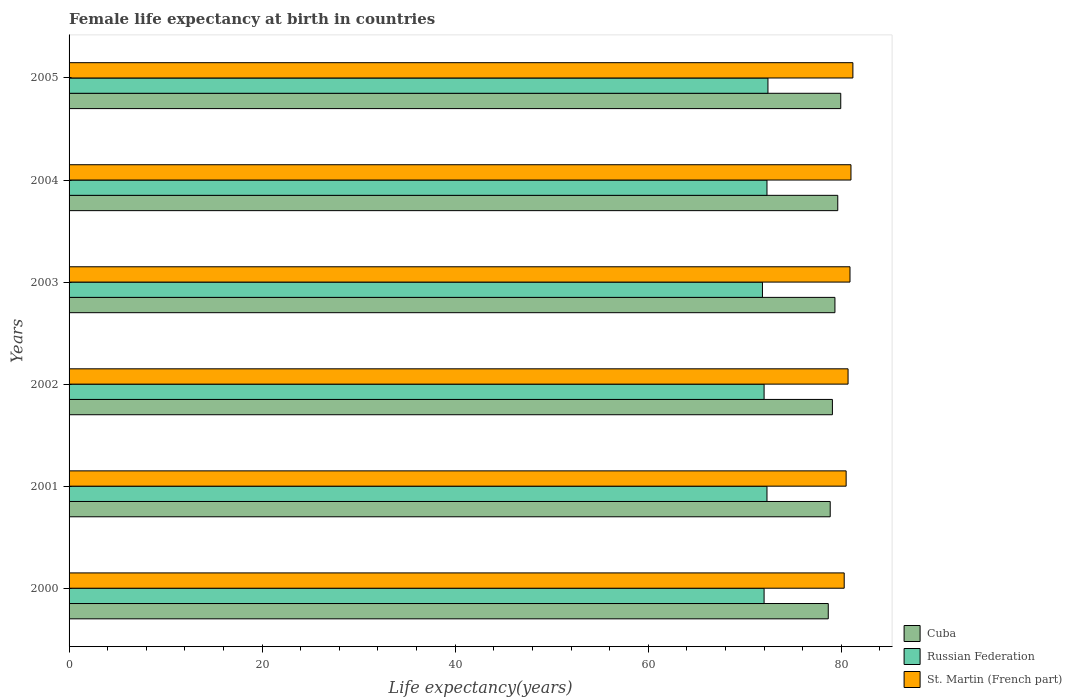How many different coloured bars are there?
Provide a short and direct response. 3. How many groups of bars are there?
Offer a terse response. 6. How many bars are there on the 2nd tick from the bottom?
Your response must be concise. 3. In how many cases, is the number of bars for a given year not equal to the number of legend labels?
Make the answer very short. 0. What is the female life expectancy at birth in Cuba in 2001?
Provide a succinct answer. 78.85. Across all years, what is the maximum female life expectancy at birth in Russian Federation?
Keep it short and to the point. 72.4. Across all years, what is the minimum female life expectancy at birth in Russian Federation?
Offer a very short reply. 71.83. In which year was the female life expectancy at birth in Russian Federation maximum?
Offer a terse response. 2005. In which year was the female life expectancy at birth in St. Martin (French part) minimum?
Provide a short and direct response. 2000. What is the total female life expectancy at birth in St. Martin (French part) in the graph?
Keep it short and to the point. 484.6. What is the difference between the female life expectancy at birth in St. Martin (French part) in 2002 and that in 2005?
Offer a terse response. -0.5. What is the difference between the female life expectancy at birth in Cuba in 2005 and the female life expectancy at birth in Russian Federation in 2001?
Your answer should be very brief. 7.64. What is the average female life expectancy at birth in Russian Federation per year?
Provide a succinct answer. 72.14. In the year 2004, what is the difference between the female life expectancy at birth in St. Martin (French part) and female life expectancy at birth in Russian Federation?
Your answer should be very brief. 8.7. In how many years, is the female life expectancy at birth in Cuba greater than 28 years?
Offer a terse response. 6. What is the ratio of the female life expectancy at birth in Cuba in 2003 to that in 2004?
Offer a terse response. 1. What is the difference between the highest and the second highest female life expectancy at birth in St. Martin (French part)?
Your response must be concise. 0.2. What is the difference between the highest and the lowest female life expectancy at birth in St. Martin (French part)?
Provide a succinct answer. 0.9. What does the 1st bar from the top in 2000 represents?
Provide a succinct answer. St. Martin (French part). What does the 3rd bar from the bottom in 2000 represents?
Provide a succinct answer. St. Martin (French part). Is it the case that in every year, the sum of the female life expectancy at birth in St. Martin (French part) and female life expectancy at birth in Cuba is greater than the female life expectancy at birth in Russian Federation?
Make the answer very short. Yes. How many bars are there?
Your answer should be compact. 18. What is the difference between two consecutive major ticks on the X-axis?
Ensure brevity in your answer.  20. Are the values on the major ticks of X-axis written in scientific E-notation?
Make the answer very short. No. Does the graph contain any zero values?
Make the answer very short. No. Does the graph contain grids?
Your answer should be very brief. No. Where does the legend appear in the graph?
Offer a terse response. Bottom right. How many legend labels are there?
Give a very brief answer. 3. What is the title of the graph?
Your answer should be compact. Female life expectancy at birth in countries. What is the label or title of the X-axis?
Keep it short and to the point. Life expectancy(years). What is the label or title of the Y-axis?
Provide a short and direct response. Years. What is the Life expectancy(years) in Cuba in 2000?
Keep it short and to the point. 78.65. What is the Life expectancy(years) of St. Martin (French part) in 2000?
Provide a short and direct response. 80.3. What is the Life expectancy(years) in Cuba in 2001?
Ensure brevity in your answer.  78.85. What is the Life expectancy(years) in Russian Federation in 2001?
Offer a terse response. 72.3. What is the Life expectancy(years) of St. Martin (French part) in 2001?
Your response must be concise. 80.5. What is the Life expectancy(years) of Cuba in 2002?
Your answer should be compact. 79.08. What is the Life expectancy(years) in Russian Federation in 2002?
Keep it short and to the point. 72. What is the Life expectancy(years) of St. Martin (French part) in 2002?
Your answer should be compact. 80.7. What is the Life expectancy(years) in Cuba in 2003?
Give a very brief answer. 79.34. What is the Life expectancy(years) in Russian Federation in 2003?
Provide a succinct answer. 71.83. What is the Life expectancy(years) of St. Martin (French part) in 2003?
Ensure brevity in your answer.  80.9. What is the Life expectancy(years) of Cuba in 2004?
Offer a terse response. 79.63. What is the Life expectancy(years) in Russian Federation in 2004?
Ensure brevity in your answer.  72.3. What is the Life expectancy(years) in St. Martin (French part) in 2004?
Your answer should be very brief. 81. What is the Life expectancy(years) of Cuba in 2005?
Your response must be concise. 79.94. What is the Life expectancy(years) of Russian Federation in 2005?
Give a very brief answer. 72.4. What is the Life expectancy(years) in St. Martin (French part) in 2005?
Your answer should be very brief. 81.2. Across all years, what is the maximum Life expectancy(years) of Cuba?
Your answer should be very brief. 79.94. Across all years, what is the maximum Life expectancy(years) of Russian Federation?
Your answer should be very brief. 72.4. Across all years, what is the maximum Life expectancy(years) of St. Martin (French part)?
Keep it short and to the point. 81.2. Across all years, what is the minimum Life expectancy(years) in Cuba?
Provide a succinct answer. 78.65. Across all years, what is the minimum Life expectancy(years) in Russian Federation?
Make the answer very short. 71.83. Across all years, what is the minimum Life expectancy(years) in St. Martin (French part)?
Your response must be concise. 80.3. What is the total Life expectancy(years) of Cuba in the graph?
Offer a terse response. 475.49. What is the total Life expectancy(years) in Russian Federation in the graph?
Your answer should be compact. 432.83. What is the total Life expectancy(years) of St. Martin (French part) in the graph?
Your response must be concise. 484.6. What is the difference between the Life expectancy(years) in Cuba in 2000 and that in 2001?
Give a very brief answer. -0.2. What is the difference between the Life expectancy(years) of Russian Federation in 2000 and that in 2001?
Make the answer very short. -0.3. What is the difference between the Life expectancy(years) of St. Martin (French part) in 2000 and that in 2001?
Ensure brevity in your answer.  -0.2. What is the difference between the Life expectancy(years) of Cuba in 2000 and that in 2002?
Offer a terse response. -0.43. What is the difference between the Life expectancy(years) in St. Martin (French part) in 2000 and that in 2002?
Ensure brevity in your answer.  -0.4. What is the difference between the Life expectancy(years) of Cuba in 2000 and that in 2003?
Provide a succinct answer. -0.69. What is the difference between the Life expectancy(years) of Russian Federation in 2000 and that in 2003?
Provide a short and direct response. 0.17. What is the difference between the Life expectancy(years) in Cuba in 2000 and that in 2004?
Your answer should be very brief. -0.98. What is the difference between the Life expectancy(years) of Cuba in 2000 and that in 2005?
Offer a very short reply. -1.29. What is the difference between the Life expectancy(years) of Cuba in 2001 and that in 2002?
Your answer should be very brief. -0.23. What is the difference between the Life expectancy(years) of Russian Federation in 2001 and that in 2002?
Your response must be concise. 0.3. What is the difference between the Life expectancy(years) in St. Martin (French part) in 2001 and that in 2002?
Offer a very short reply. -0.2. What is the difference between the Life expectancy(years) of Cuba in 2001 and that in 2003?
Make the answer very short. -0.49. What is the difference between the Life expectancy(years) in Russian Federation in 2001 and that in 2003?
Provide a short and direct response. 0.47. What is the difference between the Life expectancy(years) in St. Martin (French part) in 2001 and that in 2003?
Your answer should be very brief. -0.4. What is the difference between the Life expectancy(years) of Cuba in 2001 and that in 2004?
Your answer should be very brief. -0.78. What is the difference between the Life expectancy(years) of St. Martin (French part) in 2001 and that in 2004?
Ensure brevity in your answer.  -0.5. What is the difference between the Life expectancy(years) in Cuba in 2001 and that in 2005?
Offer a very short reply. -1.09. What is the difference between the Life expectancy(years) in Russian Federation in 2001 and that in 2005?
Your answer should be compact. -0.1. What is the difference between the Life expectancy(years) of St. Martin (French part) in 2001 and that in 2005?
Give a very brief answer. -0.7. What is the difference between the Life expectancy(years) in Cuba in 2002 and that in 2003?
Offer a very short reply. -0.26. What is the difference between the Life expectancy(years) in Russian Federation in 2002 and that in 2003?
Your answer should be very brief. 0.17. What is the difference between the Life expectancy(years) of St. Martin (French part) in 2002 and that in 2003?
Ensure brevity in your answer.  -0.2. What is the difference between the Life expectancy(years) in Cuba in 2002 and that in 2004?
Offer a terse response. -0.55. What is the difference between the Life expectancy(years) in St. Martin (French part) in 2002 and that in 2004?
Offer a very short reply. -0.3. What is the difference between the Life expectancy(years) of Cuba in 2002 and that in 2005?
Make the answer very short. -0.86. What is the difference between the Life expectancy(years) of St. Martin (French part) in 2002 and that in 2005?
Ensure brevity in your answer.  -0.5. What is the difference between the Life expectancy(years) in Cuba in 2003 and that in 2004?
Your response must be concise. -0.29. What is the difference between the Life expectancy(years) in Russian Federation in 2003 and that in 2004?
Offer a very short reply. -0.47. What is the difference between the Life expectancy(years) of Cuba in 2003 and that in 2005?
Your response must be concise. -0.6. What is the difference between the Life expectancy(years) in Russian Federation in 2003 and that in 2005?
Keep it short and to the point. -0.57. What is the difference between the Life expectancy(years) of Cuba in 2004 and that in 2005?
Provide a short and direct response. -0.31. What is the difference between the Life expectancy(years) of Russian Federation in 2004 and that in 2005?
Make the answer very short. -0.1. What is the difference between the Life expectancy(years) of St. Martin (French part) in 2004 and that in 2005?
Make the answer very short. -0.2. What is the difference between the Life expectancy(years) in Cuba in 2000 and the Life expectancy(years) in Russian Federation in 2001?
Offer a very short reply. 6.35. What is the difference between the Life expectancy(years) in Cuba in 2000 and the Life expectancy(years) in St. Martin (French part) in 2001?
Offer a terse response. -1.85. What is the difference between the Life expectancy(years) of Russian Federation in 2000 and the Life expectancy(years) of St. Martin (French part) in 2001?
Offer a very short reply. -8.5. What is the difference between the Life expectancy(years) in Cuba in 2000 and the Life expectancy(years) in Russian Federation in 2002?
Your answer should be compact. 6.65. What is the difference between the Life expectancy(years) in Cuba in 2000 and the Life expectancy(years) in St. Martin (French part) in 2002?
Keep it short and to the point. -2.05. What is the difference between the Life expectancy(years) in Cuba in 2000 and the Life expectancy(years) in Russian Federation in 2003?
Your answer should be compact. 6.82. What is the difference between the Life expectancy(years) of Cuba in 2000 and the Life expectancy(years) of St. Martin (French part) in 2003?
Offer a very short reply. -2.25. What is the difference between the Life expectancy(years) in Russian Federation in 2000 and the Life expectancy(years) in St. Martin (French part) in 2003?
Keep it short and to the point. -8.9. What is the difference between the Life expectancy(years) in Cuba in 2000 and the Life expectancy(years) in Russian Federation in 2004?
Ensure brevity in your answer.  6.35. What is the difference between the Life expectancy(years) in Cuba in 2000 and the Life expectancy(years) in St. Martin (French part) in 2004?
Make the answer very short. -2.35. What is the difference between the Life expectancy(years) in Russian Federation in 2000 and the Life expectancy(years) in St. Martin (French part) in 2004?
Provide a short and direct response. -9. What is the difference between the Life expectancy(years) of Cuba in 2000 and the Life expectancy(years) of Russian Federation in 2005?
Give a very brief answer. 6.25. What is the difference between the Life expectancy(years) of Cuba in 2000 and the Life expectancy(years) of St. Martin (French part) in 2005?
Ensure brevity in your answer.  -2.55. What is the difference between the Life expectancy(years) in Russian Federation in 2000 and the Life expectancy(years) in St. Martin (French part) in 2005?
Your answer should be compact. -9.2. What is the difference between the Life expectancy(years) of Cuba in 2001 and the Life expectancy(years) of Russian Federation in 2002?
Give a very brief answer. 6.85. What is the difference between the Life expectancy(years) of Cuba in 2001 and the Life expectancy(years) of St. Martin (French part) in 2002?
Give a very brief answer. -1.85. What is the difference between the Life expectancy(years) of Cuba in 2001 and the Life expectancy(years) of Russian Federation in 2003?
Give a very brief answer. 7.02. What is the difference between the Life expectancy(years) in Cuba in 2001 and the Life expectancy(years) in St. Martin (French part) in 2003?
Offer a terse response. -2.05. What is the difference between the Life expectancy(years) in Cuba in 2001 and the Life expectancy(years) in Russian Federation in 2004?
Your answer should be compact. 6.55. What is the difference between the Life expectancy(years) of Cuba in 2001 and the Life expectancy(years) of St. Martin (French part) in 2004?
Give a very brief answer. -2.15. What is the difference between the Life expectancy(years) of Cuba in 2001 and the Life expectancy(years) of Russian Federation in 2005?
Your answer should be very brief. 6.45. What is the difference between the Life expectancy(years) in Cuba in 2001 and the Life expectancy(years) in St. Martin (French part) in 2005?
Provide a short and direct response. -2.35. What is the difference between the Life expectancy(years) of Cuba in 2002 and the Life expectancy(years) of Russian Federation in 2003?
Ensure brevity in your answer.  7.25. What is the difference between the Life expectancy(years) of Cuba in 2002 and the Life expectancy(years) of St. Martin (French part) in 2003?
Give a very brief answer. -1.82. What is the difference between the Life expectancy(years) of Cuba in 2002 and the Life expectancy(years) of Russian Federation in 2004?
Offer a very short reply. 6.78. What is the difference between the Life expectancy(years) of Cuba in 2002 and the Life expectancy(years) of St. Martin (French part) in 2004?
Make the answer very short. -1.92. What is the difference between the Life expectancy(years) of Russian Federation in 2002 and the Life expectancy(years) of St. Martin (French part) in 2004?
Provide a succinct answer. -9. What is the difference between the Life expectancy(years) in Cuba in 2002 and the Life expectancy(years) in Russian Federation in 2005?
Keep it short and to the point. 6.68. What is the difference between the Life expectancy(years) of Cuba in 2002 and the Life expectancy(years) of St. Martin (French part) in 2005?
Your answer should be compact. -2.12. What is the difference between the Life expectancy(years) of Russian Federation in 2002 and the Life expectancy(years) of St. Martin (French part) in 2005?
Make the answer very short. -9.2. What is the difference between the Life expectancy(years) of Cuba in 2003 and the Life expectancy(years) of Russian Federation in 2004?
Offer a terse response. 7.04. What is the difference between the Life expectancy(years) in Cuba in 2003 and the Life expectancy(years) in St. Martin (French part) in 2004?
Provide a short and direct response. -1.66. What is the difference between the Life expectancy(years) of Russian Federation in 2003 and the Life expectancy(years) of St. Martin (French part) in 2004?
Ensure brevity in your answer.  -9.17. What is the difference between the Life expectancy(years) of Cuba in 2003 and the Life expectancy(years) of Russian Federation in 2005?
Give a very brief answer. 6.94. What is the difference between the Life expectancy(years) in Cuba in 2003 and the Life expectancy(years) in St. Martin (French part) in 2005?
Offer a terse response. -1.86. What is the difference between the Life expectancy(years) in Russian Federation in 2003 and the Life expectancy(years) in St. Martin (French part) in 2005?
Give a very brief answer. -9.37. What is the difference between the Life expectancy(years) of Cuba in 2004 and the Life expectancy(years) of Russian Federation in 2005?
Your response must be concise. 7.23. What is the difference between the Life expectancy(years) in Cuba in 2004 and the Life expectancy(years) in St. Martin (French part) in 2005?
Your answer should be very brief. -1.57. What is the difference between the Life expectancy(years) of Russian Federation in 2004 and the Life expectancy(years) of St. Martin (French part) in 2005?
Your answer should be very brief. -8.9. What is the average Life expectancy(years) of Cuba per year?
Keep it short and to the point. 79.25. What is the average Life expectancy(years) in Russian Federation per year?
Keep it short and to the point. 72.14. What is the average Life expectancy(years) in St. Martin (French part) per year?
Offer a terse response. 80.77. In the year 2000, what is the difference between the Life expectancy(years) of Cuba and Life expectancy(years) of Russian Federation?
Ensure brevity in your answer.  6.65. In the year 2000, what is the difference between the Life expectancy(years) in Cuba and Life expectancy(years) in St. Martin (French part)?
Keep it short and to the point. -1.65. In the year 2000, what is the difference between the Life expectancy(years) in Russian Federation and Life expectancy(years) in St. Martin (French part)?
Ensure brevity in your answer.  -8.3. In the year 2001, what is the difference between the Life expectancy(years) of Cuba and Life expectancy(years) of Russian Federation?
Provide a short and direct response. 6.55. In the year 2001, what is the difference between the Life expectancy(years) of Cuba and Life expectancy(years) of St. Martin (French part)?
Offer a terse response. -1.65. In the year 2001, what is the difference between the Life expectancy(years) in Russian Federation and Life expectancy(years) in St. Martin (French part)?
Offer a very short reply. -8.2. In the year 2002, what is the difference between the Life expectancy(years) of Cuba and Life expectancy(years) of Russian Federation?
Ensure brevity in your answer.  7.08. In the year 2002, what is the difference between the Life expectancy(years) of Cuba and Life expectancy(years) of St. Martin (French part)?
Your answer should be compact. -1.62. In the year 2003, what is the difference between the Life expectancy(years) in Cuba and Life expectancy(years) in Russian Federation?
Provide a short and direct response. 7.51. In the year 2003, what is the difference between the Life expectancy(years) of Cuba and Life expectancy(years) of St. Martin (French part)?
Your answer should be very brief. -1.56. In the year 2003, what is the difference between the Life expectancy(years) of Russian Federation and Life expectancy(years) of St. Martin (French part)?
Offer a very short reply. -9.07. In the year 2004, what is the difference between the Life expectancy(years) in Cuba and Life expectancy(years) in Russian Federation?
Keep it short and to the point. 7.33. In the year 2004, what is the difference between the Life expectancy(years) in Cuba and Life expectancy(years) in St. Martin (French part)?
Your response must be concise. -1.37. In the year 2004, what is the difference between the Life expectancy(years) in Russian Federation and Life expectancy(years) in St. Martin (French part)?
Keep it short and to the point. -8.7. In the year 2005, what is the difference between the Life expectancy(years) in Cuba and Life expectancy(years) in Russian Federation?
Provide a short and direct response. 7.54. In the year 2005, what is the difference between the Life expectancy(years) of Cuba and Life expectancy(years) of St. Martin (French part)?
Your answer should be compact. -1.26. What is the ratio of the Life expectancy(years) of Cuba in 2000 to that in 2002?
Your answer should be compact. 0.99. What is the ratio of the Life expectancy(years) of Russian Federation in 2000 to that in 2002?
Give a very brief answer. 1. What is the ratio of the Life expectancy(years) in Russian Federation in 2000 to that in 2003?
Make the answer very short. 1. What is the ratio of the Life expectancy(years) in St. Martin (French part) in 2000 to that in 2003?
Make the answer very short. 0.99. What is the ratio of the Life expectancy(years) of Cuba in 2000 to that in 2004?
Your answer should be compact. 0.99. What is the ratio of the Life expectancy(years) in Russian Federation in 2000 to that in 2004?
Ensure brevity in your answer.  1. What is the ratio of the Life expectancy(years) in St. Martin (French part) in 2000 to that in 2004?
Your response must be concise. 0.99. What is the ratio of the Life expectancy(years) in Cuba in 2000 to that in 2005?
Ensure brevity in your answer.  0.98. What is the ratio of the Life expectancy(years) of Russian Federation in 2000 to that in 2005?
Make the answer very short. 0.99. What is the ratio of the Life expectancy(years) in St. Martin (French part) in 2000 to that in 2005?
Offer a terse response. 0.99. What is the ratio of the Life expectancy(years) in Russian Federation in 2001 to that in 2002?
Give a very brief answer. 1. What is the ratio of the Life expectancy(years) of St. Martin (French part) in 2001 to that in 2002?
Your answer should be very brief. 1. What is the ratio of the Life expectancy(years) in St. Martin (French part) in 2001 to that in 2003?
Offer a terse response. 1. What is the ratio of the Life expectancy(years) in Cuba in 2001 to that in 2004?
Make the answer very short. 0.99. What is the ratio of the Life expectancy(years) in St. Martin (French part) in 2001 to that in 2004?
Keep it short and to the point. 0.99. What is the ratio of the Life expectancy(years) in Cuba in 2001 to that in 2005?
Make the answer very short. 0.99. What is the ratio of the Life expectancy(years) of Russian Federation in 2001 to that in 2005?
Give a very brief answer. 1. What is the ratio of the Life expectancy(years) of St. Martin (French part) in 2001 to that in 2005?
Give a very brief answer. 0.99. What is the ratio of the Life expectancy(years) in Cuba in 2002 to that in 2003?
Your answer should be very brief. 1. What is the ratio of the Life expectancy(years) in Russian Federation in 2002 to that in 2003?
Your response must be concise. 1. What is the ratio of the Life expectancy(years) of St. Martin (French part) in 2002 to that in 2003?
Make the answer very short. 1. What is the ratio of the Life expectancy(years) of Cuba in 2002 to that in 2005?
Make the answer very short. 0.99. What is the ratio of the Life expectancy(years) of Russian Federation in 2002 to that in 2005?
Ensure brevity in your answer.  0.99. What is the ratio of the Life expectancy(years) of St. Martin (French part) in 2003 to that in 2004?
Offer a very short reply. 1. What is the ratio of the Life expectancy(years) in Russian Federation in 2003 to that in 2005?
Ensure brevity in your answer.  0.99. What is the ratio of the Life expectancy(years) of St. Martin (French part) in 2003 to that in 2005?
Provide a short and direct response. 1. What is the ratio of the Life expectancy(years) of Cuba in 2004 to that in 2005?
Your answer should be compact. 1. What is the ratio of the Life expectancy(years) of St. Martin (French part) in 2004 to that in 2005?
Offer a terse response. 1. What is the difference between the highest and the second highest Life expectancy(years) in Cuba?
Keep it short and to the point. 0.31. What is the difference between the highest and the second highest Life expectancy(years) in Russian Federation?
Keep it short and to the point. 0.1. What is the difference between the highest and the lowest Life expectancy(years) in Cuba?
Your answer should be compact. 1.29. What is the difference between the highest and the lowest Life expectancy(years) of Russian Federation?
Your answer should be very brief. 0.57. 